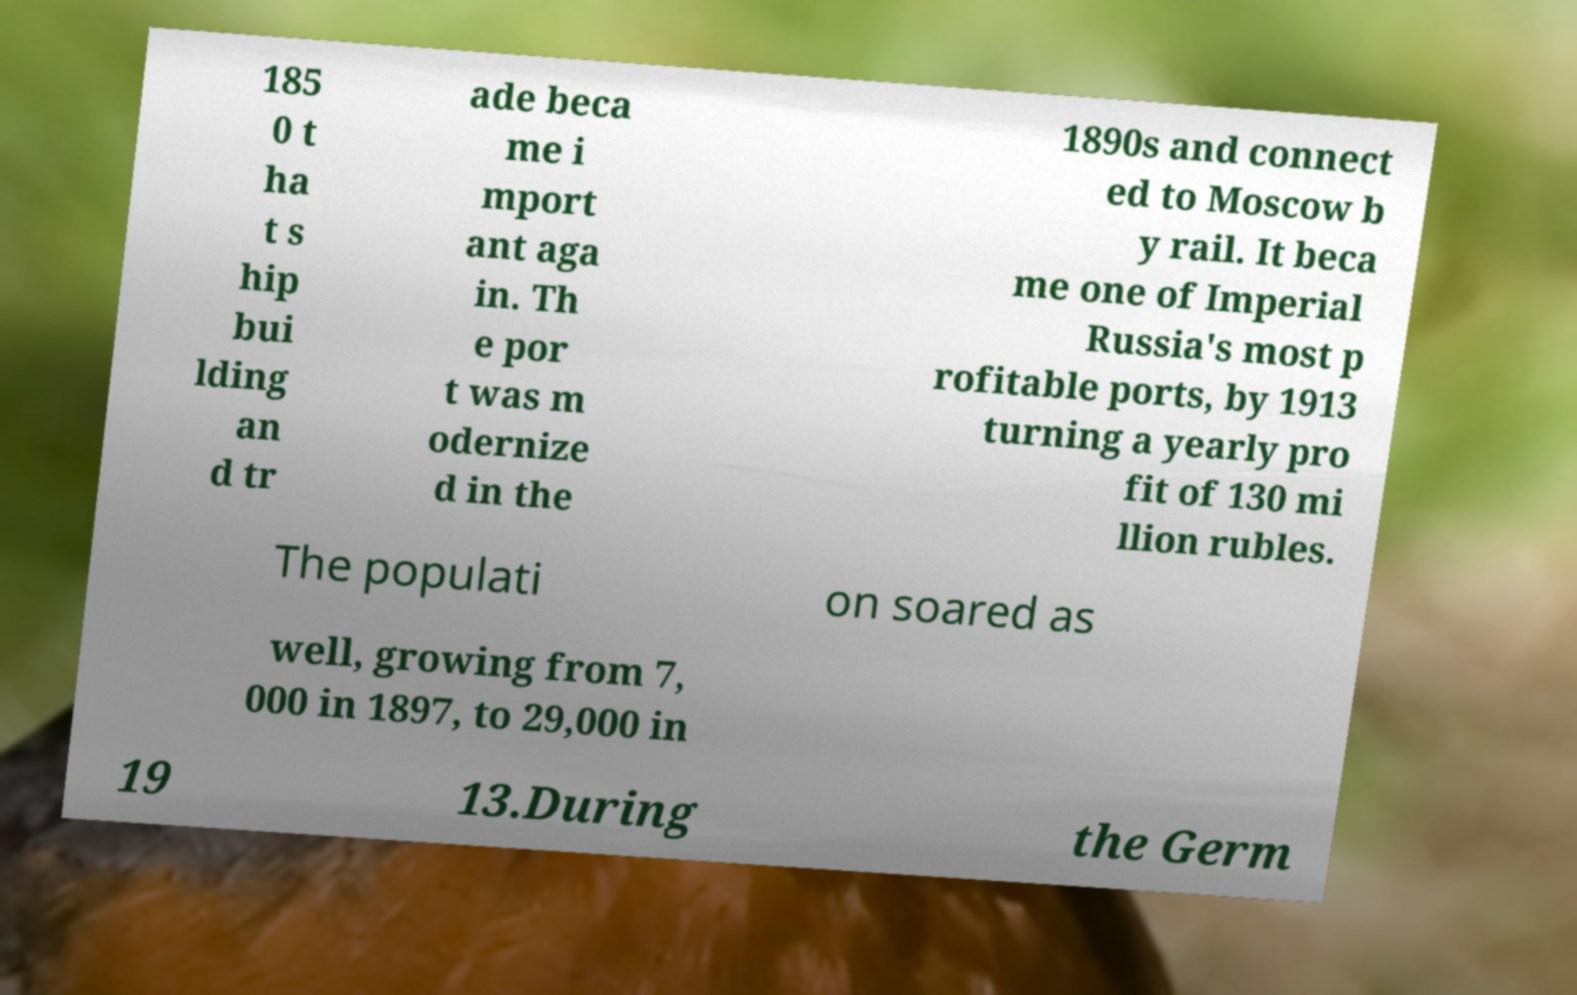Could you extract and type out the text from this image? 185 0 t ha t s hip bui lding an d tr ade beca me i mport ant aga in. Th e por t was m odernize d in the 1890s and connect ed to Moscow b y rail. It beca me one of Imperial Russia's most p rofitable ports, by 1913 turning a yearly pro fit of 130 mi llion rubles. The populati on soared as well, growing from 7, 000 in 1897, to 29,000 in 19 13.During the Germ 